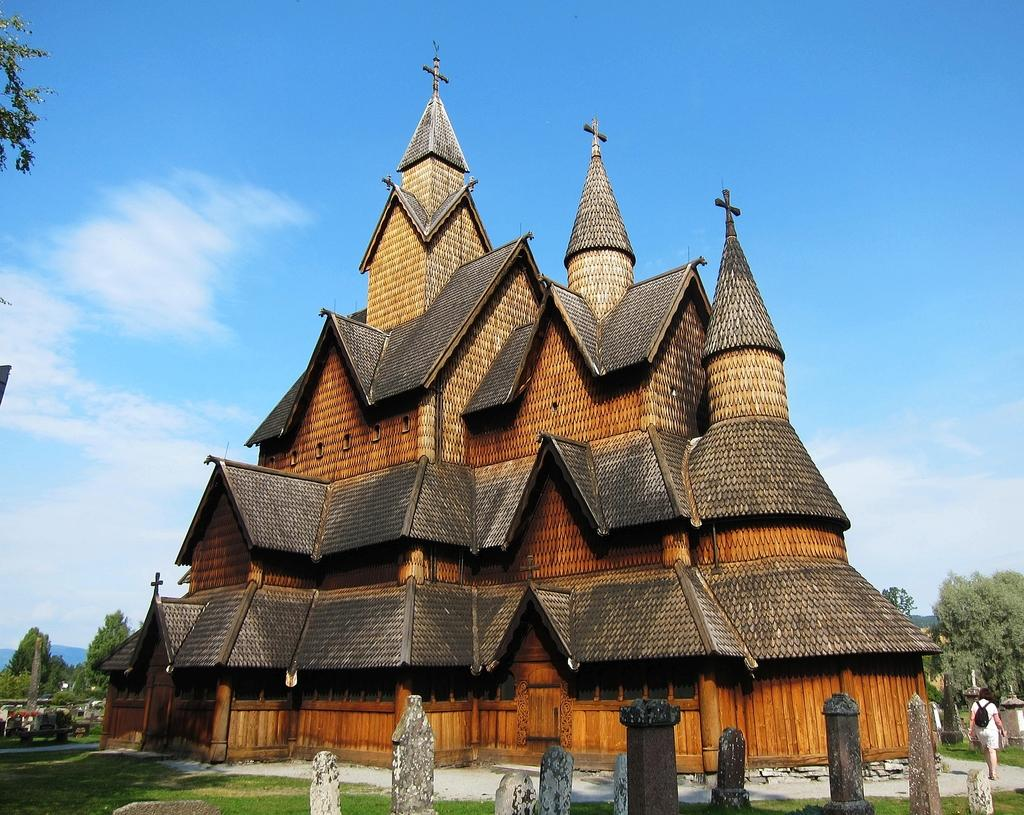What type of building is in the image? There is a cathedral in the image. What objects are present in the image besides the cathedral? There are poles in the image. What is the person in the image doing? The person is walking in the image. What is the person wearing? The person is wearing clothes. What is the person carrying? The person is carrying a bag. What type of terrain is visible in the image? There is grass visible in the image. What type of vegetation is present in the image? There are trees in the image. What part of the natural environment is visible in the image? The sky is visible in the image. Can you see the ocean in the image? No, there is no ocean visible in the image. 